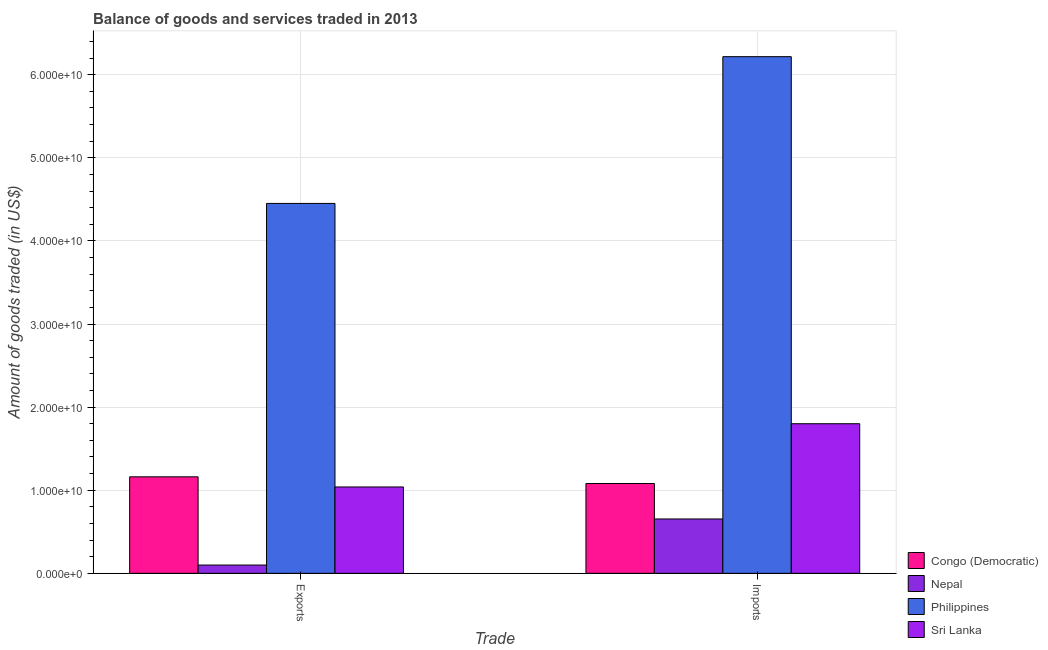How many different coloured bars are there?
Your answer should be very brief. 4. How many groups of bars are there?
Your answer should be very brief. 2. Are the number of bars per tick equal to the number of legend labels?
Offer a very short reply. Yes. Are the number of bars on each tick of the X-axis equal?
Your answer should be compact. Yes. How many bars are there on the 2nd tick from the right?
Offer a very short reply. 4. What is the label of the 2nd group of bars from the left?
Your response must be concise. Imports. What is the amount of goods exported in Philippines?
Keep it short and to the point. 4.45e+1. Across all countries, what is the maximum amount of goods imported?
Your response must be concise. 6.22e+1. Across all countries, what is the minimum amount of goods imported?
Offer a very short reply. 6.54e+09. In which country was the amount of goods imported minimum?
Offer a terse response. Nepal. What is the total amount of goods exported in the graph?
Provide a succinct answer. 6.75e+1. What is the difference between the amount of goods exported in Sri Lanka and that in Philippines?
Give a very brief answer. -3.41e+1. What is the difference between the amount of goods exported in Sri Lanka and the amount of goods imported in Philippines?
Provide a succinct answer. -5.18e+1. What is the average amount of goods imported per country?
Keep it short and to the point. 2.44e+1. What is the difference between the amount of goods exported and amount of goods imported in Congo (Democratic)?
Ensure brevity in your answer.  8.05e+08. What is the ratio of the amount of goods imported in Nepal to that in Sri Lanka?
Your answer should be very brief. 0.36. Is the amount of goods exported in Nepal less than that in Congo (Democratic)?
Your answer should be compact. Yes. In how many countries, is the amount of goods imported greater than the average amount of goods imported taken over all countries?
Provide a succinct answer. 1. What does the 1st bar from the left in Imports represents?
Ensure brevity in your answer.  Congo (Democratic). How many bars are there?
Give a very brief answer. 8. Are all the bars in the graph horizontal?
Provide a short and direct response. No. What is the difference between two consecutive major ticks on the Y-axis?
Offer a very short reply. 1.00e+1. Are the values on the major ticks of Y-axis written in scientific E-notation?
Provide a succinct answer. Yes. Does the graph contain any zero values?
Offer a very short reply. No. Where does the legend appear in the graph?
Give a very brief answer. Bottom right. How many legend labels are there?
Your response must be concise. 4. How are the legend labels stacked?
Provide a short and direct response. Vertical. What is the title of the graph?
Provide a succinct answer. Balance of goods and services traded in 2013. Does "Arab World" appear as one of the legend labels in the graph?
Your answer should be compact. No. What is the label or title of the X-axis?
Provide a succinct answer. Trade. What is the label or title of the Y-axis?
Offer a terse response. Amount of goods traded (in US$). What is the Amount of goods traded (in US$) in Congo (Democratic) in Exports?
Offer a very short reply. 1.16e+1. What is the Amount of goods traded (in US$) of Nepal in Exports?
Offer a very short reply. 9.98e+08. What is the Amount of goods traded (in US$) of Philippines in Exports?
Your answer should be compact. 4.45e+1. What is the Amount of goods traded (in US$) of Sri Lanka in Exports?
Give a very brief answer. 1.04e+1. What is the Amount of goods traded (in US$) of Congo (Democratic) in Imports?
Keep it short and to the point. 1.08e+1. What is the Amount of goods traded (in US$) in Nepal in Imports?
Provide a short and direct response. 6.54e+09. What is the Amount of goods traded (in US$) of Philippines in Imports?
Keep it short and to the point. 6.22e+1. What is the Amount of goods traded (in US$) of Sri Lanka in Imports?
Keep it short and to the point. 1.80e+1. Across all Trade, what is the maximum Amount of goods traded (in US$) in Congo (Democratic)?
Offer a terse response. 1.16e+1. Across all Trade, what is the maximum Amount of goods traded (in US$) of Nepal?
Give a very brief answer. 6.54e+09. Across all Trade, what is the maximum Amount of goods traded (in US$) in Philippines?
Offer a terse response. 6.22e+1. Across all Trade, what is the maximum Amount of goods traded (in US$) in Sri Lanka?
Your answer should be compact. 1.80e+1. Across all Trade, what is the minimum Amount of goods traded (in US$) in Congo (Democratic)?
Your answer should be compact. 1.08e+1. Across all Trade, what is the minimum Amount of goods traded (in US$) of Nepal?
Give a very brief answer. 9.98e+08. Across all Trade, what is the minimum Amount of goods traded (in US$) of Philippines?
Provide a succinct answer. 4.45e+1. Across all Trade, what is the minimum Amount of goods traded (in US$) in Sri Lanka?
Provide a succinct answer. 1.04e+1. What is the total Amount of goods traded (in US$) of Congo (Democratic) in the graph?
Give a very brief answer. 2.24e+1. What is the total Amount of goods traded (in US$) of Nepal in the graph?
Make the answer very short. 7.54e+09. What is the total Amount of goods traded (in US$) of Philippines in the graph?
Your answer should be compact. 1.07e+11. What is the total Amount of goods traded (in US$) of Sri Lanka in the graph?
Provide a short and direct response. 2.84e+1. What is the difference between the Amount of goods traded (in US$) of Congo (Democratic) in Exports and that in Imports?
Your answer should be compact. 8.05e+08. What is the difference between the Amount of goods traded (in US$) of Nepal in Exports and that in Imports?
Provide a short and direct response. -5.54e+09. What is the difference between the Amount of goods traded (in US$) of Philippines in Exports and that in Imports?
Ensure brevity in your answer.  -1.77e+1. What is the difference between the Amount of goods traded (in US$) in Sri Lanka in Exports and that in Imports?
Keep it short and to the point. -7.61e+09. What is the difference between the Amount of goods traded (in US$) of Congo (Democratic) in Exports and the Amount of goods traded (in US$) of Nepal in Imports?
Give a very brief answer. 5.07e+09. What is the difference between the Amount of goods traded (in US$) of Congo (Democratic) in Exports and the Amount of goods traded (in US$) of Philippines in Imports?
Offer a terse response. -5.06e+1. What is the difference between the Amount of goods traded (in US$) of Congo (Democratic) in Exports and the Amount of goods traded (in US$) of Sri Lanka in Imports?
Give a very brief answer. -6.39e+09. What is the difference between the Amount of goods traded (in US$) in Nepal in Exports and the Amount of goods traded (in US$) in Philippines in Imports?
Provide a succinct answer. -6.12e+1. What is the difference between the Amount of goods traded (in US$) of Nepal in Exports and the Amount of goods traded (in US$) of Sri Lanka in Imports?
Provide a short and direct response. -1.70e+1. What is the difference between the Amount of goods traded (in US$) of Philippines in Exports and the Amount of goods traded (in US$) of Sri Lanka in Imports?
Your answer should be compact. 2.65e+1. What is the average Amount of goods traded (in US$) in Congo (Democratic) per Trade?
Your response must be concise. 1.12e+1. What is the average Amount of goods traded (in US$) of Nepal per Trade?
Offer a very short reply. 3.77e+09. What is the average Amount of goods traded (in US$) in Philippines per Trade?
Give a very brief answer. 5.33e+1. What is the average Amount of goods traded (in US$) of Sri Lanka per Trade?
Your answer should be compact. 1.42e+1. What is the difference between the Amount of goods traded (in US$) in Congo (Democratic) and Amount of goods traded (in US$) in Nepal in Exports?
Your response must be concise. 1.06e+1. What is the difference between the Amount of goods traded (in US$) of Congo (Democratic) and Amount of goods traded (in US$) of Philippines in Exports?
Your response must be concise. -3.29e+1. What is the difference between the Amount of goods traded (in US$) in Congo (Democratic) and Amount of goods traded (in US$) in Sri Lanka in Exports?
Give a very brief answer. 1.22e+09. What is the difference between the Amount of goods traded (in US$) in Nepal and Amount of goods traded (in US$) in Philippines in Exports?
Provide a succinct answer. -4.35e+1. What is the difference between the Amount of goods traded (in US$) in Nepal and Amount of goods traded (in US$) in Sri Lanka in Exports?
Provide a succinct answer. -9.40e+09. What is the difference between the Amount of goods traded (in US$) in Philippines and Amount of goods traded (in US$) in Sri Lanka in Exports?
Make the answer very short. 3.41e+1. What is the difference between the Amount of goods traded (in US$) in Congo (Democratic) and Amount of goods traded (in US$) in Nepal in Imports?
Give a very brief answer. 4.27e+09. What is the difference between the Amount of goods traded (in US$) in Congo (Democratic) and Amount of goods traded (in US$) in Philippines in Imports?
Offer a very short reply. -5.14e+1. What is the difference between the Amount of goods traded (in US$) of Congo (Democratic) and Amount of goods traded (in US$) of Sri Lanka in Imports?
Give a very brief answer. -7.19e+09. What is the difference between the Amount of goods traded (in US$) in Nepal and Amount of goods traded (in US$) in Philippines in Imports?
Make the answer very short. -5.56e+1. What is the difference between the Amount of goods traded (in US$) of Nepal and Amount of goods traded (in US$) of Sri Lanka in Imports?
Offer a terse response. -1.15e+1. What is the difference between the Amount of goods traded (in US$) of Philippines and Amount of goods traded (in US$) of Sri Lanka in Imports?
Ensure brevity in your answer.  4.42e+1. What is the ratio of the Amount of goods traded (in US$) in Congo (Democratic) in Exports to that in Imports?
Keep it short and to the point. 1.07. What is the ratio of the Amount of goods traded (in US$) of Nepal in Exports to that in Imports?
Provide a succinct answer. 0.15. What is the ratio of the Amount of goods traded (in US$) of Philippines in Exports to that in Imports?
Provide a short and direct response. 0.72. What is the ratio of the Amount of goods traded (in US$) in Sri Lanka in Exports to that in Imports?
Your response must be concise. 0.58. What is the difference between the highest and the second highest Amount of goods traded (in US$) in Congo (Democratic)?
Provide a short and direct response. 8.05e+08. What is the difference between the highest and the second highest Amount of goods traded (in US$) in Nepal?
Offer a very short reply. 5.54e+09. What is the difference between the highest and the second highest Amount of goods traded (in US$) in Philippines?
Provide a succinct answer. 1.77e+1. What is the difference between the highest and the second highest Amount of goods traded (in US$) in Sri Lanka?
Your answer should be very brief. 7.61e+09. What is the difference between the highest and the lowest Amount of goods traded (in US$) of Congo (Democratic)?
Keep it short and to the point. 8.05e+08. What is the difference between the highest and the lowest Amount of goods traded (in US$) in Nepal?
Provide a short and direct response. 5.54e+09. What is the difference between the highest and the lowest Amount of goods traded (in US$) in Philippines?
Make the answer very short. 1.77e+1. What is the difference between the highest and the lowest Amount of goods traded (in US$) in Sri Lanka?
Make the answer very short. 7.61e+09. 